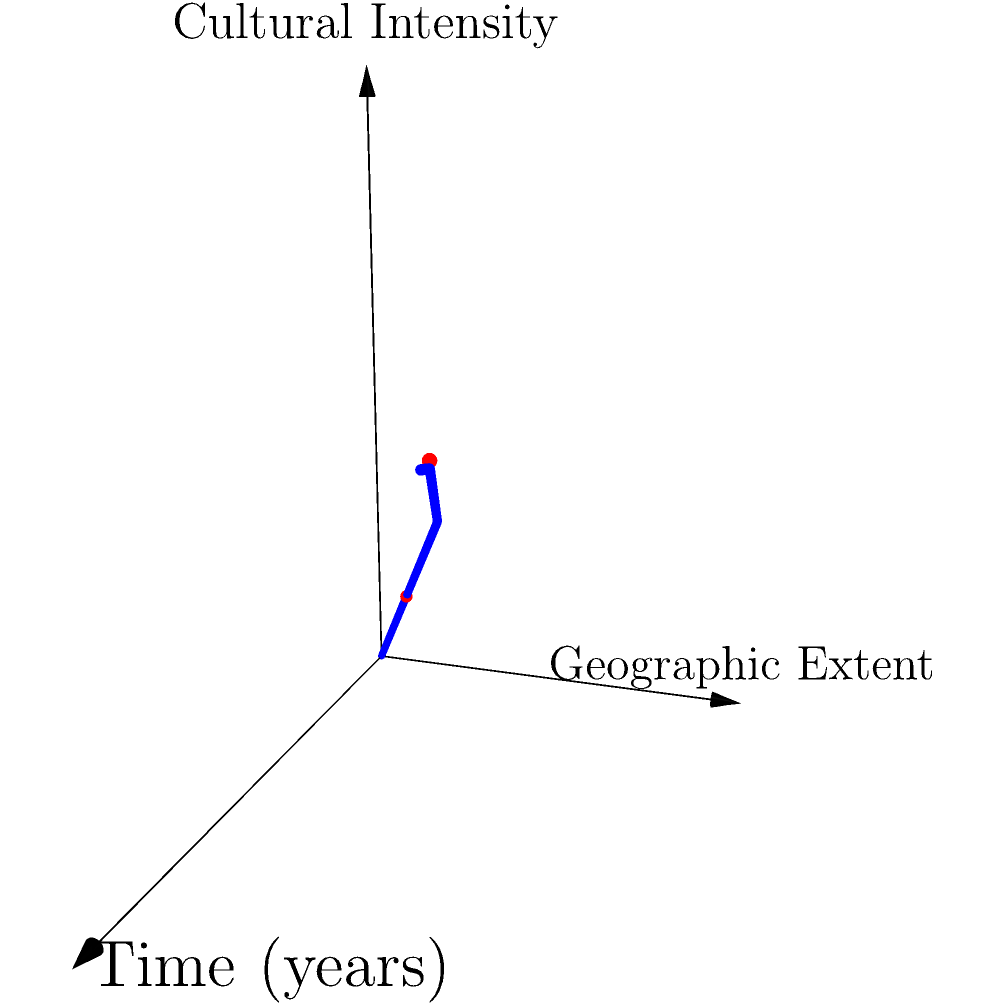In the 3D coordinate system representing the spread of Hellenistic culture, where Time (years) is on the x-axis, Geographic Extent on the y-axis, and Cultural Intensity on the z-axis, what does the blue curve suggest about the relationship between these three factors? Additionally, what might the two red points signify in the context of Hellenistic cultural expansion? To answer this question, let's analyze the 3D coordinate system step by step:

1. The blue curve represents the spread of Hellenistic culture over time.

2. The curve's shape suggests:
   a) An initial rapid increase in all three dimensions (Time, Geographic Extent, and Cultural Intensity).
   b) A gradual slowing of growth as time progresses, particularly in Geographic Extent and Cultural Intensity.

3. The relationship between the factors:
   a) As time increases, both Geographic Extent and Cultural Intensity generally increase.
   b) The rate of increase is not constant, implying periods of faster and slower expansion.
   c) The curve's steepness decreases over time, suggesting a saturation point in expansion and cultural influence.

4. The two red points on the curve likely represent significant events or periods in Hellenistic history:
   a) The first point (0.8, 0.8, 0.8) might represent an early stage of Hellenistic expansion, such as the initial conquests of Alexander the Great.
   b) The second point (2.4, 2, 2.2) could signify a later period of consolidation, perhaps during the height of the Ptolemaic or Seleucid empires.

5. The difference between the points shows:
   a) An increase in all dimensions, but with Geographic Extent and Cultural Intensity growing more slowly than time.
   b) This suggests that while Hellenistic influence continued to spread, its rate of expansion and intensification slowed over time.

In conclusion, the graph illustrates the non-linear nature of Hellenistic cultural expansion, showing initial rapid growth followed by a more gradual spread and intensification over time.
Answer: Non-linear expansion with initial rapid growth, followed by gradual spread and intensification; red points likely represent key historical events in Hellenistic expansion. 